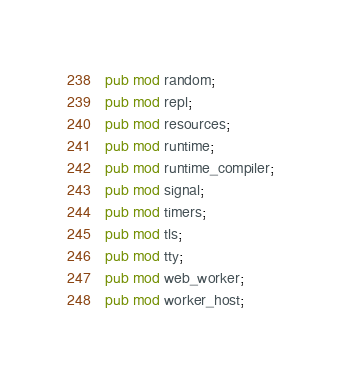<code> <loc_0><loc_0><loc_500><loc_500><_Rust_>pub mod random;
pub mod repl;
pub mod resources;
pub mod runtime;
pub mod runtime_compiler;
pub mod signal;
pub mod timers;
pub mod tls;
pub mod tty;
pub mod web_worker;
pub mod worker_host;
</code> 